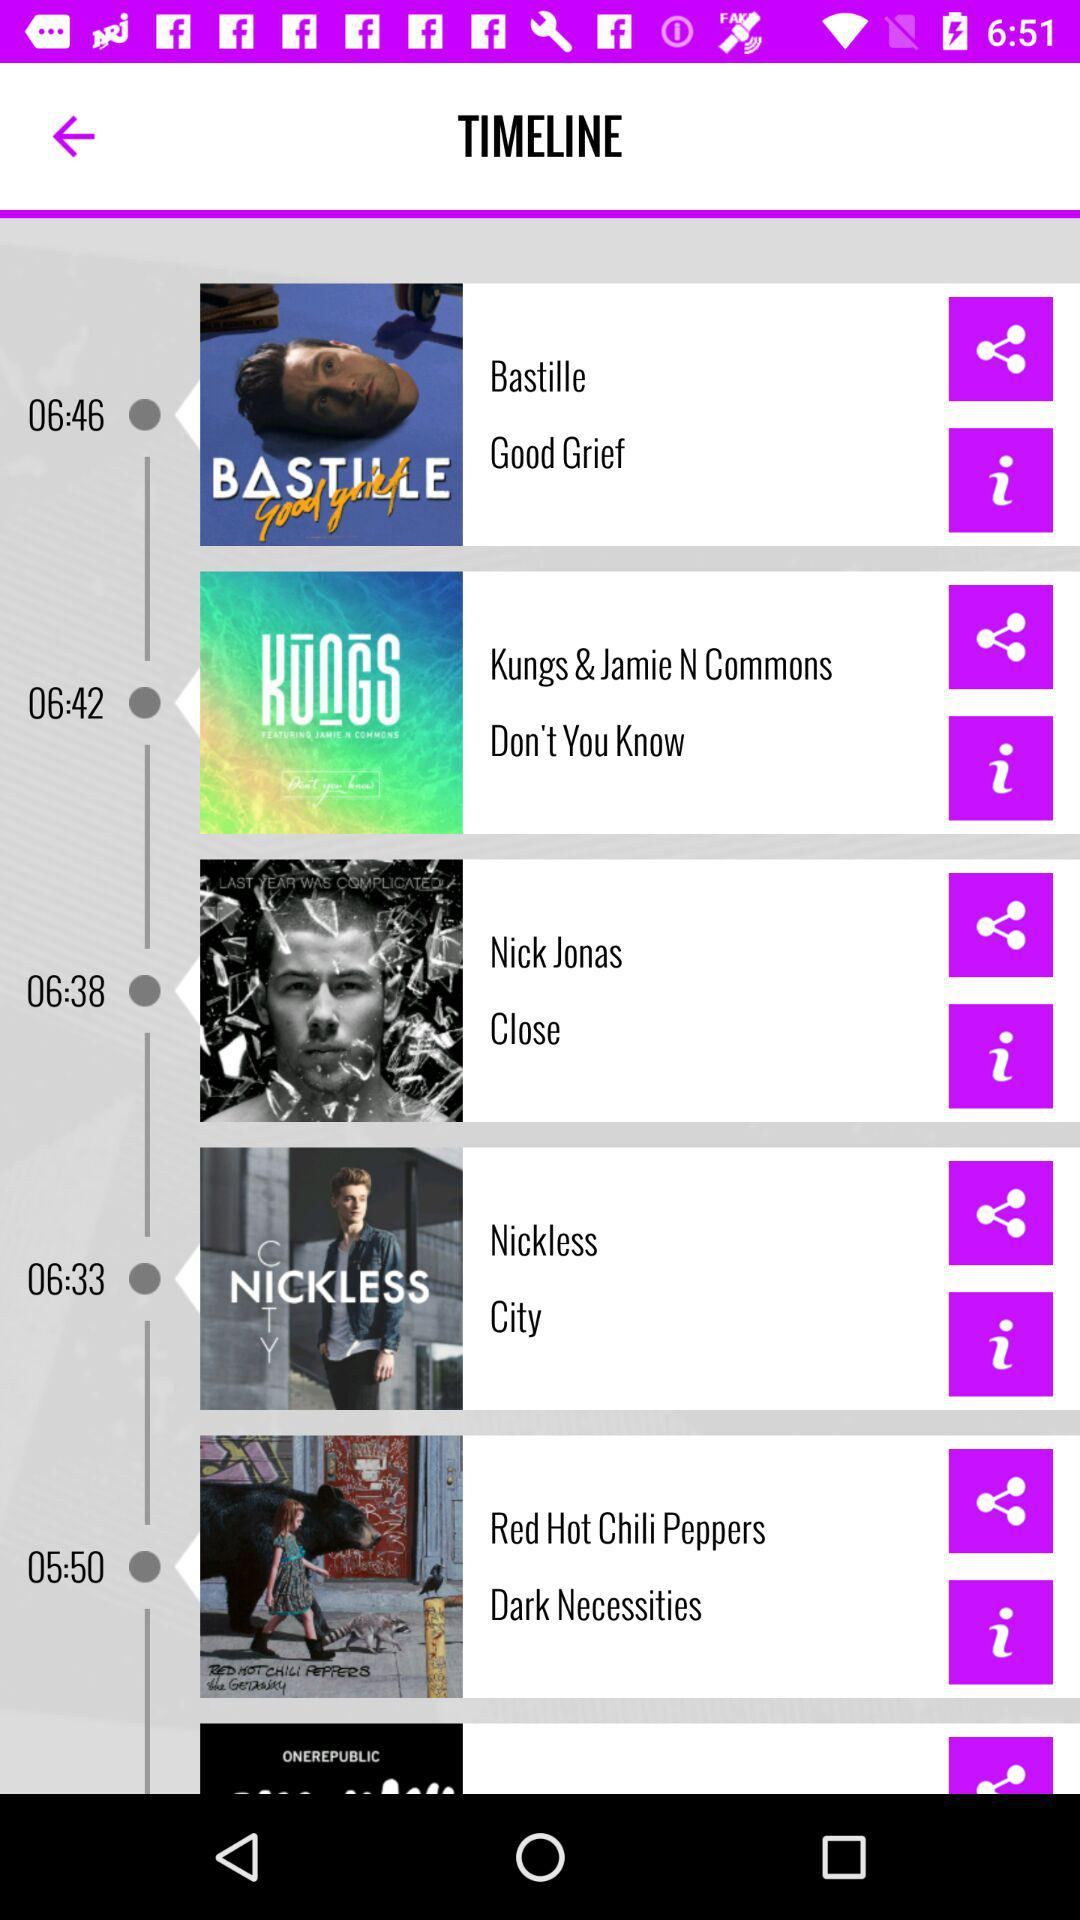What is the duration of the song "Don't You Know"? The duration is 6 minutes and 42 seconds. 